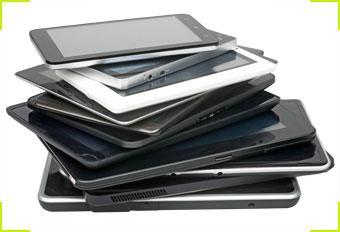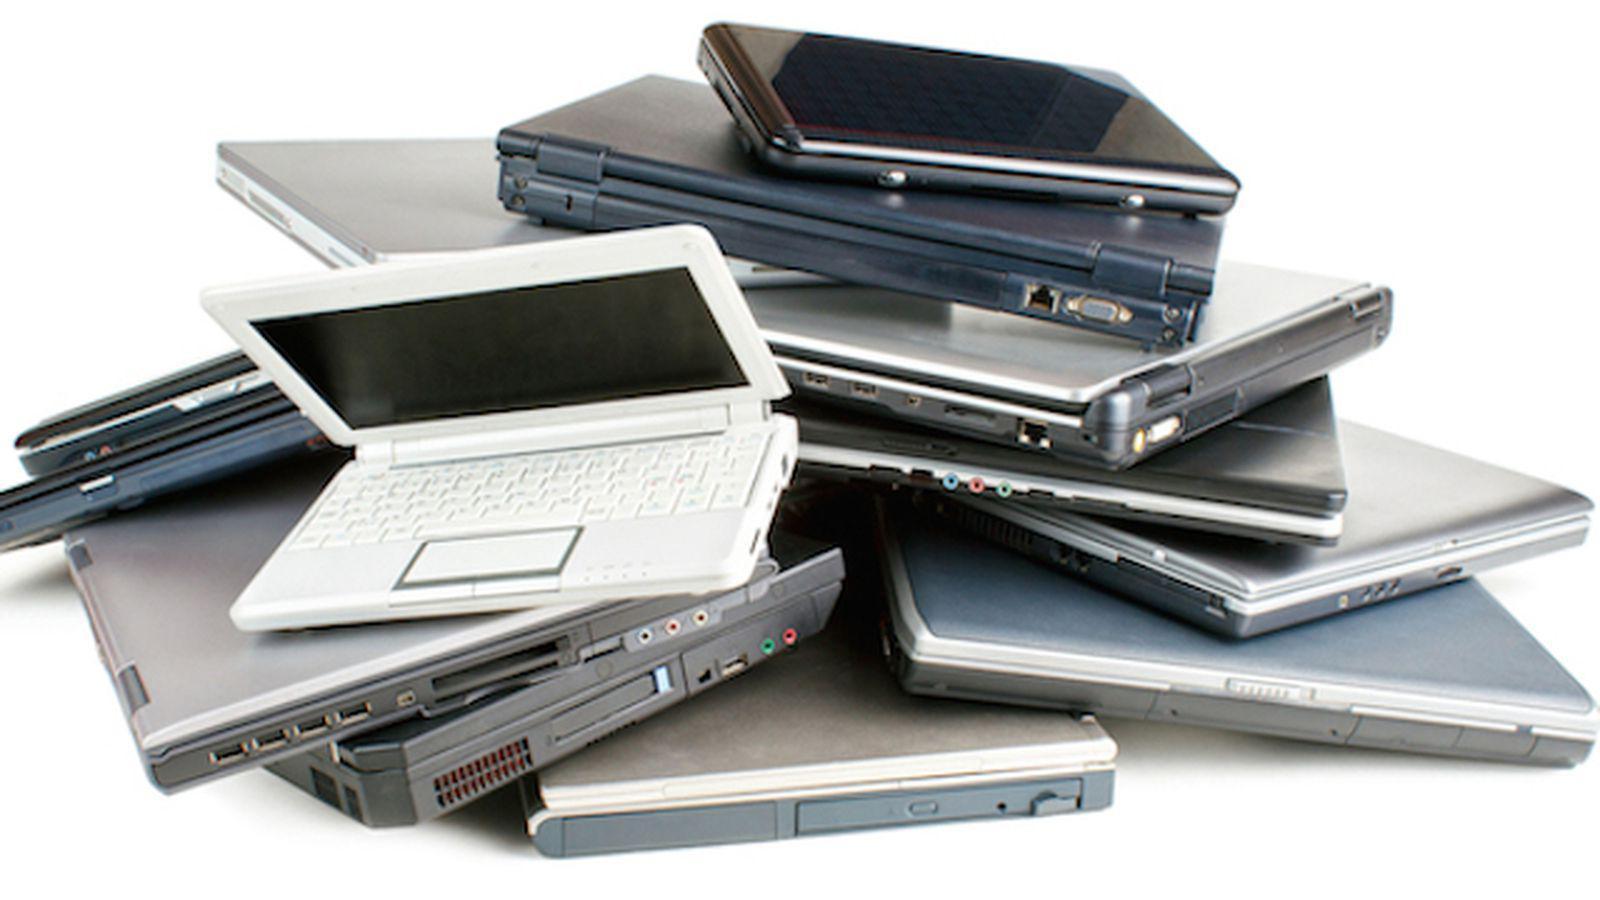The first image is the image on the left, the second image is the image on the right. For the images shown, is this caption "An open laptop is sitting on a stack of at least three rectangular items in the left image." true? Answer yes or no. No. The first image is the image on the left, the second image is the image on the right. Evaluate the accuracy of this statement regarding the images: "Electronic devices are stacked upon each other in each of the images.". Is it true? Answer yes or no. Yes. 